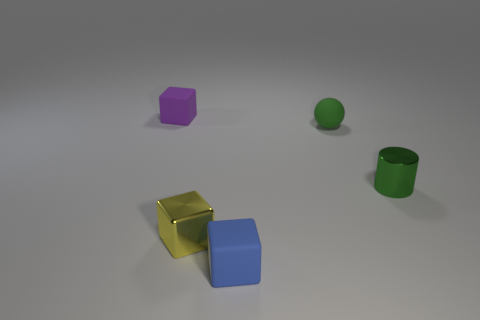Subtract all yellow blocks. How many blocks are left? 2 Subtract all cylinders. How many objects are left? 4 Subtract 1 blocks. How many blocks are left? 2 Add 5 yellow rubber cylinders. How many yellow rubber cylinders exist? 5 Add 5 tiny green matte spheres. How many objects exist? 10 Subtract all blue blocks. How many blocks are left? 2 Subtract 0 blue cylinders. How many objects are left? 5 Subtract all green blocks. Subtract all cyan spheres. How many blocks are left? 3 Subtract all purple cylinders. How many brown cubes are left? 0 Subtract all rubber things. Subtract all tiny metal objects. How many objects are left? 0 